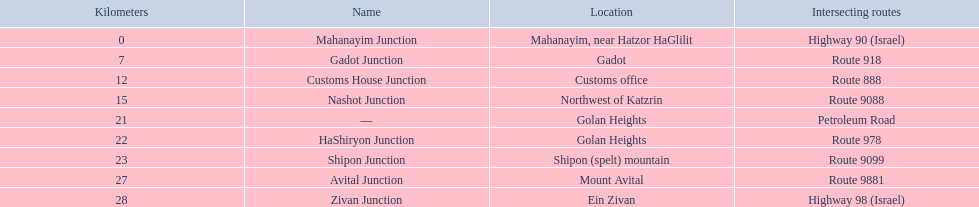Would you be able to parse every entry in this table? {'header': ['Kilometers', 'Name', 'Location', 'Intersecting routes'], 'rows': [['0', 'Mahanayim Junction', 'Mahanayim, near Hatzor HaGlilit', 'Highway 90 (Israel)'], ['7', 'Gadot Junction', 'Gadot', 'Route 918'], ['12', 'Customs House Junction', 'Customs office', 'Route 888'], ['15', 'Nashot Junction', 'Northwest of Katzrin', 'Route 9088'], ['21', '—', 'Golan Heights', 'Petroleum Road'], ['22', 'HaShiryon Junction', 'Golan Heights', 'Route 978'], ['23', 'Shipon Junction', 'Shipon (spelt) mountain', 'Route 9099'], ['27', 'Avital Junction', 'Mount Avital', 'Route 9881'], ['28', 'Zivan Junction', 'Ein Zivan', 'Highway 98 (Israel)']]} Which connection on highway 91 is more proximate to ein zivan, gadot connection or shipon connection? Gadot Junction. 